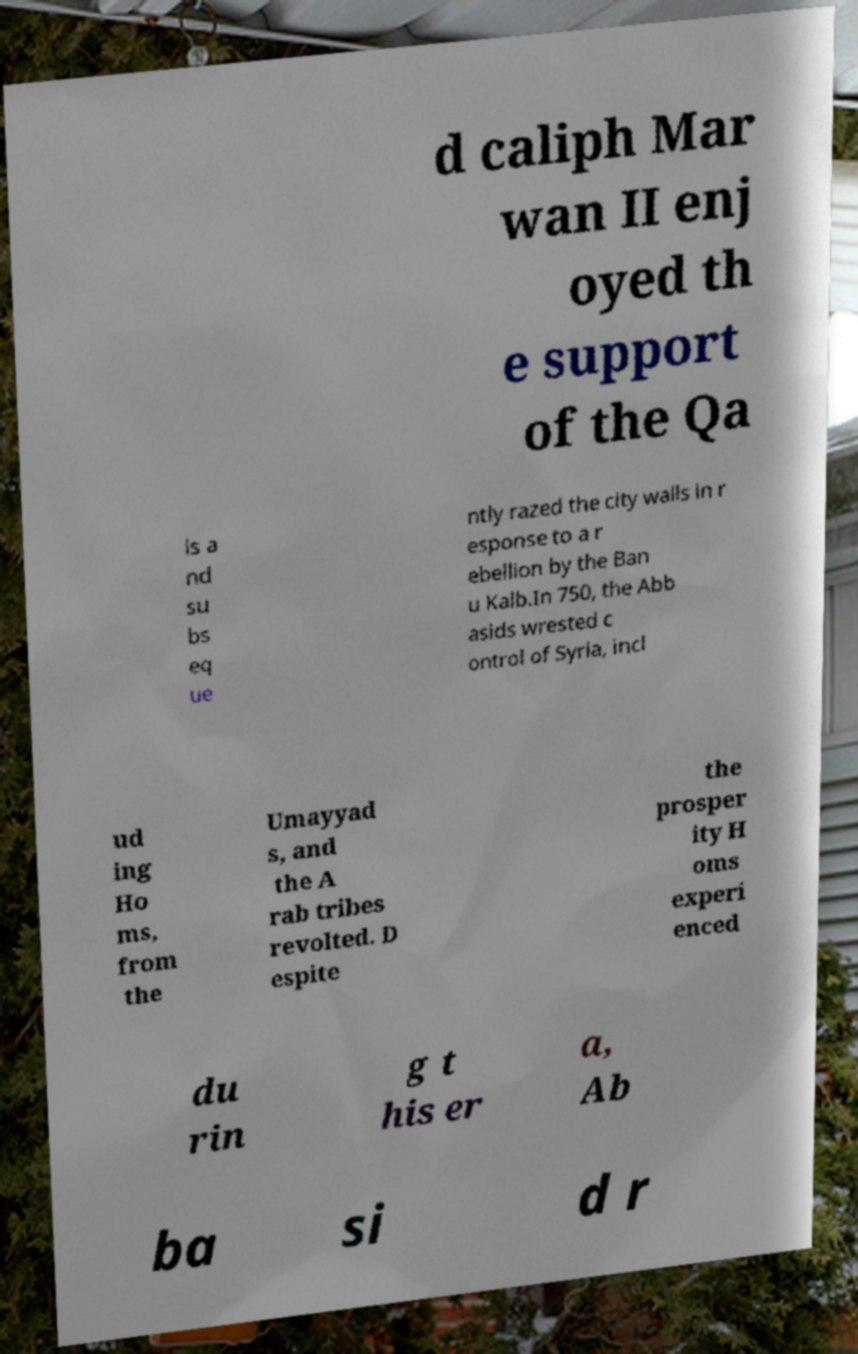Could you extract and type out the text from this image? d caliph Mar wan II enj oyed th e support of the Qa is a nd su bs eq ue ntly razed the city walls in r esponse to a r ebellion by the Ban u Kalb.In 750, the Abb asids wrested c ontrol of Syria, incl ud ing Ho ms, from the Umayyad s, and the A rab tribes revolted. D espite the prosper ity H oms experi enced du rin g t his er a, Ab ba si d r 